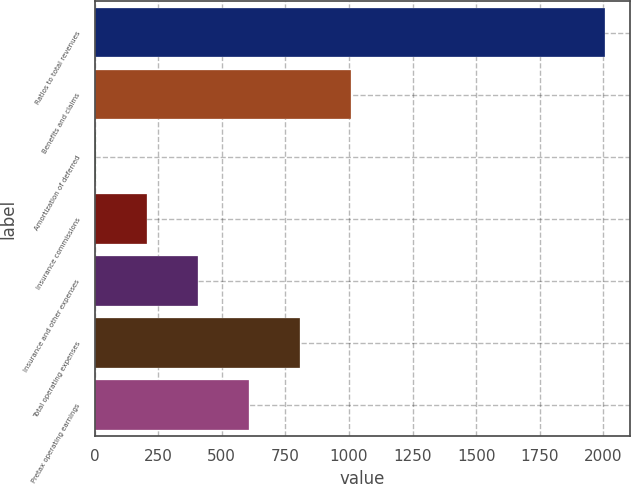Convert chart. <chart><loc_0><loc_0><loc_500><loc_500><bar_chart><fcel>Ratios to total revenues<fcel>Benefits and claims<fcel>Amortization of deferred<fcel>Insurance commissions<fcel>Insurance and other expenses<fcel>Total operating expenses<fcel>Pretax operating earnings<nl><fcel>2006<fcel>1006.6<fcel>7.2<fcel>207.08<fcel>406.96<fcel>806.72<fcel>606.84<nl></chart> 